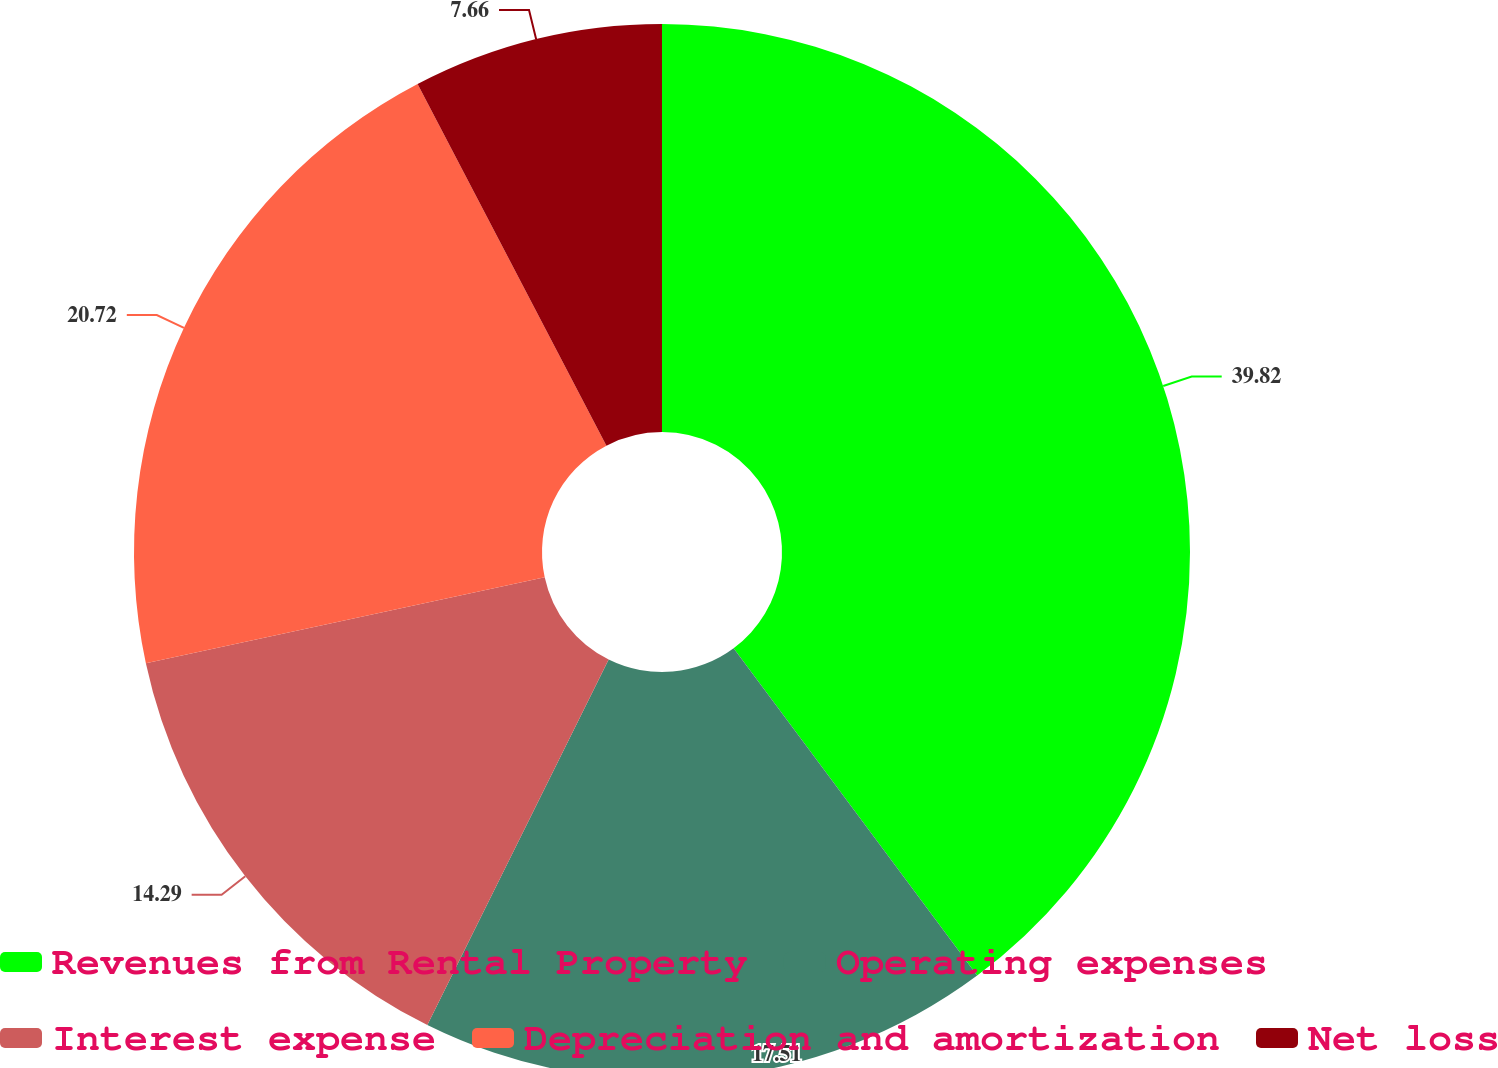Convert chart to OTSL. <chart><loc_0><loc_0><loc_500><loc_500><pie_chart><fcel>Revenues from Rental Property<fcel>Operating expenses<fcel>Interest expense<fcel>Depreciation and amortization<fcel>Net loss<nl><fcel>39.82%<fcel>17.51%<fcel>14.29%<fcel>20.72%<fcel>7.66%<nl></chart> 